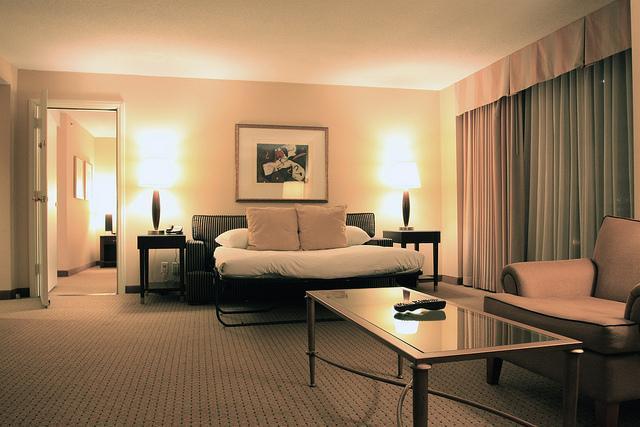How many couches are in the picture?
Give a very brief answer. 3. 